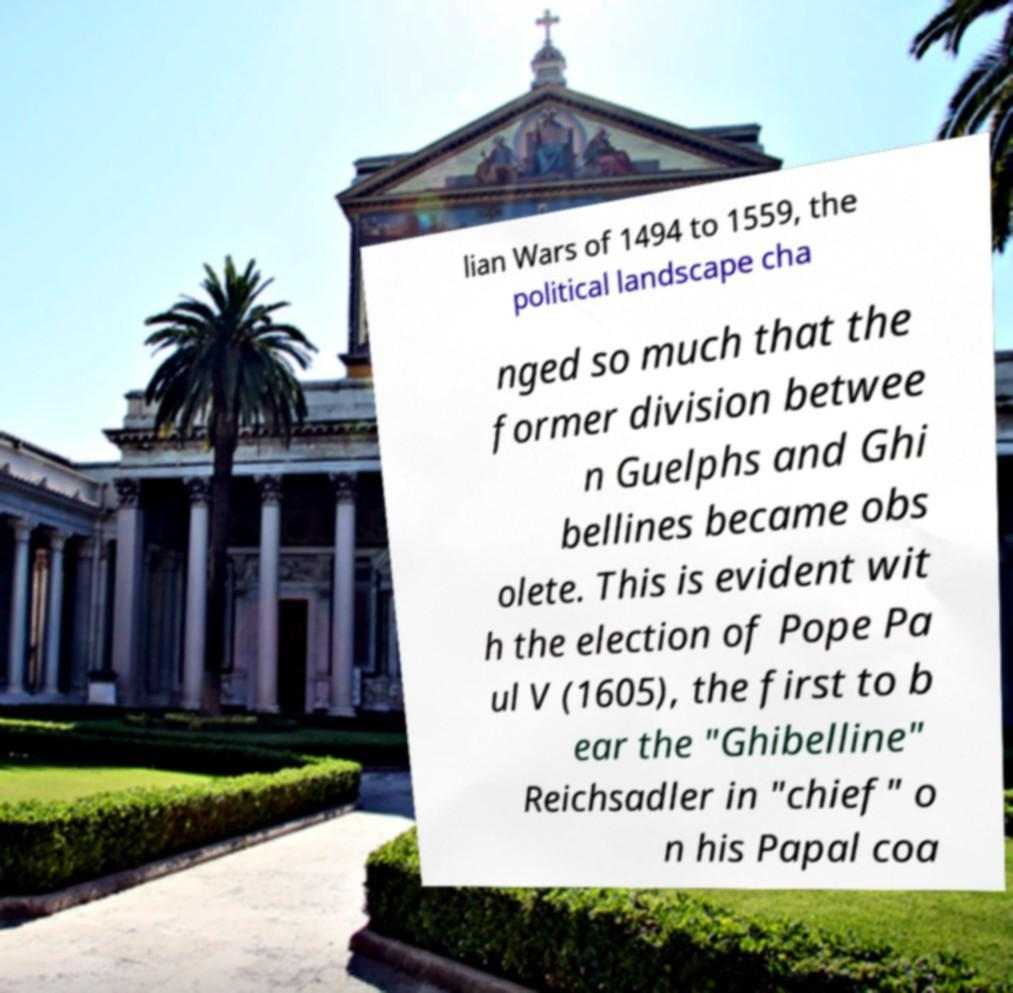There's text embedded in this image that I need extracted. Can you transcribe it verbatim? lian Wars of 1494 to 1559, the political landscape cha nged so much that the former division betwee n Guelphs and Ghi bellines became obs olete. This is evident wit h the election of Pope Pa ul V (1605), the first to b ear the "Ghibelline" Reichsadler in "chief" o n his Papal coa 